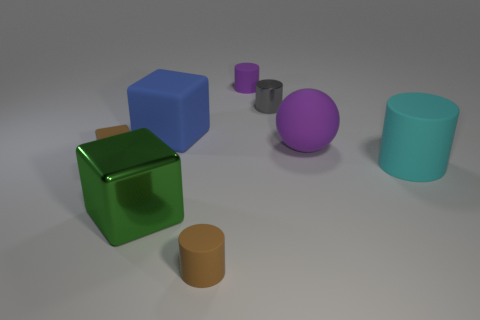Does the brown rubber block have the same size as the metal cube?
Offer a terse response. No. What is the size of the cyan object that is the same shape as the gray object?
Offer a very short reply. Large. Is there any other thing that is the same size as the green shiny block?
Provide a succinct answer. Yes. What is the material of the small object on the left side of the small matte cylinder that is in front of the large green object?
Provide a succinct answer. Rubber. Do the small gray thing and the blue rubber object have the same shape?
Give a very brief answer. No. How many metal objects are left of the big blue block and behind the tiny brown cube?
Ensure brevity in your answer.  0. Is the number of large things to the left of the blue block the same as the number of gray metallic cylinders to the left of the large purple rubber thing?
Offer a very short reply. Yes. Does the brown matte object to the left of the large blue thing have the same size as the cube behind the purple sphere?
Ensure brevity in your answer.  No. There is a tiny thing that is both on the left side of the small purple cylinder and behind the big green thing; what material is it?
Your answer should be very brief. Rubber. Are there fewer tiny blocks than big things?
Keep it short and to the point. Yes. 